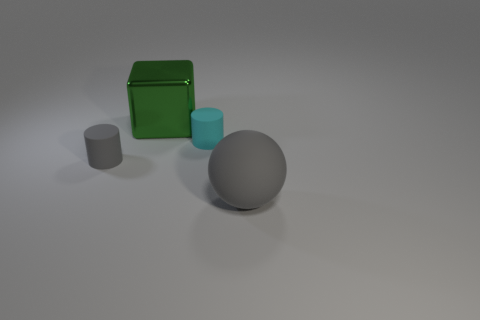Subtract all cyan cylinders. How many cylinders are left? 1 Subtract 1 gray cylinders. How many objects are left? 3 Subtract all cubes. How many objects are left? 3 Subtract 1 blocks. How many blocks are left? 0 Subtract all brown cylinders. Subtract all green cubes. How many cylinders are left? 2 Subtract all purple balls. How many cyan cylinders are left? 1 Subtract all large gray matte things. Subtract all big purple cubes. How many objects are left? 3 Add 1 large cubes. How many large cubes are left? 2 Add 4 green shiny objects. How many green shiny objects exist? 5 Add 2 small cyan things. How many objects exist? 6 